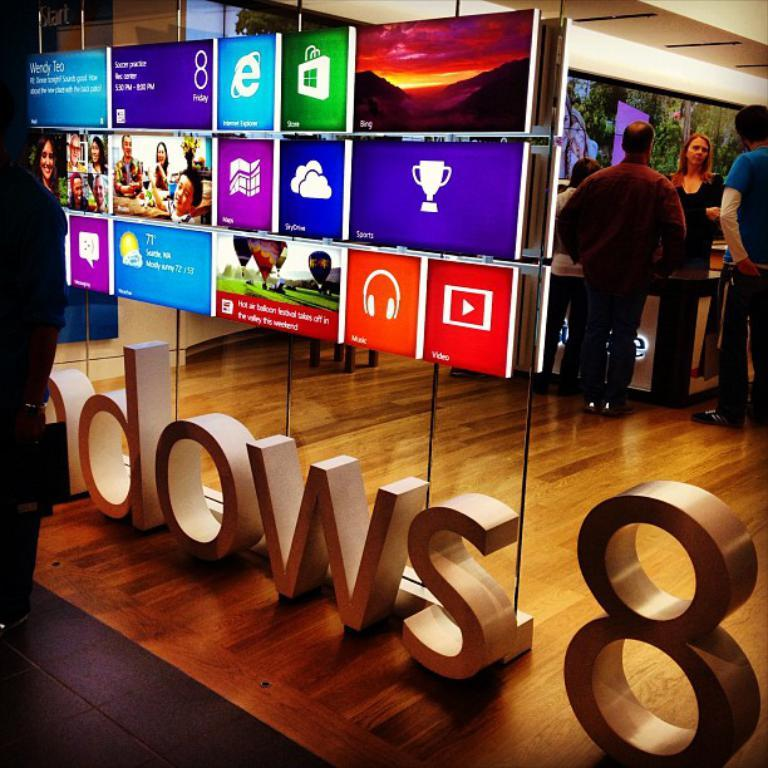What is happening in the store in the image? There are people standing in the store. What can be seen on the walls or other surfaces in the store? There are advertisement screens in the store. Can you describe the position of one of the people in the image? There is a man standing on the side. What type of chair is the squirrel sitting on in the image? There is no squirrel or chair present in the image. What kind of music can be heard playing in the store in the image? The image does not provide any information about music being played in the store. 